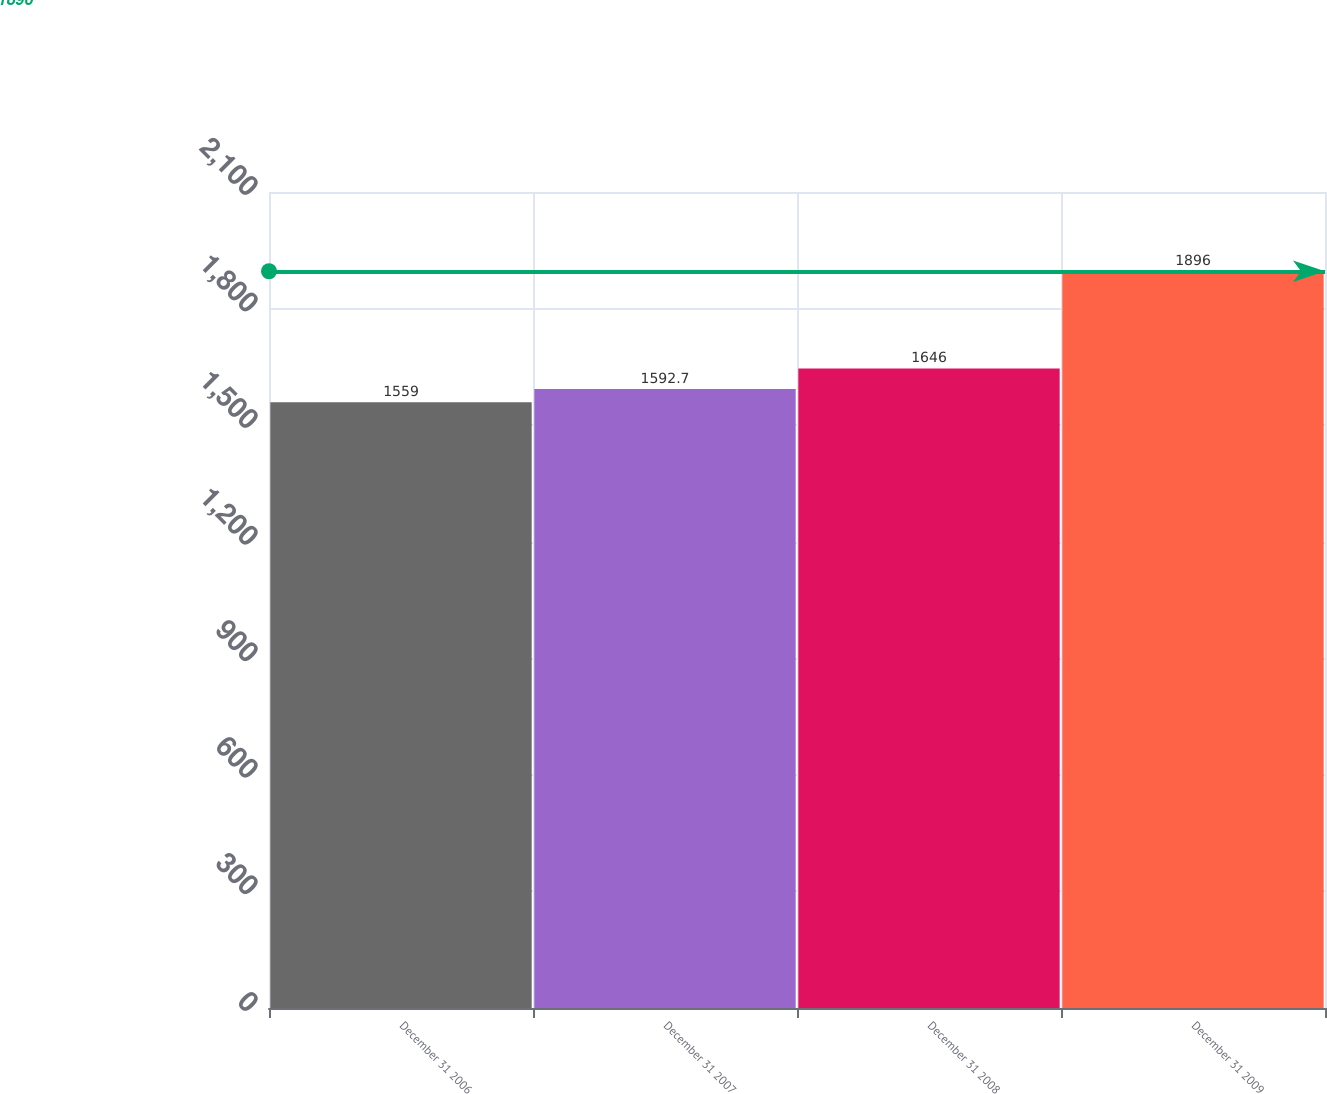Convert chart. <chart><loc_0><loc_0><loc_500><loc_500><bar_chart><fcel>December 31 2006<fcel>December 31 2007<fcel>December 31 2008<fcel>December 31 2009<nl><fcel>1559<fcel>1592.7<fcel>1646<fcel>1896<nl></chart> 